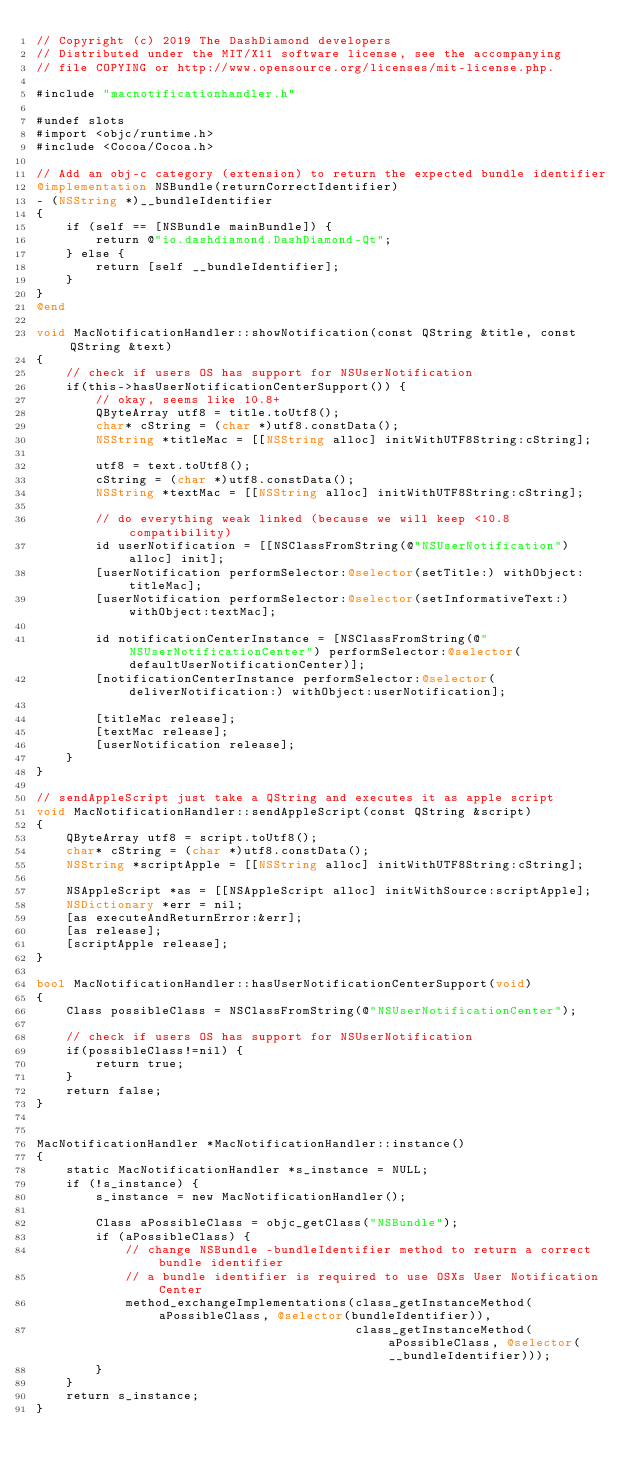Convert code to text. <code><loc_0><loc_0><loc_500><loc_500><_ObjectiveC_>// Copyright (c) 2019 The DashDiamond developers
// Distributed under the MIT/X11 software license, see the accompanying
// file COPYING or http://www.opensource.org/licenses/mit-license.php.

#include "macnotificationhandler.h"

#undef slots
#import <objc/runtime.h>
#include <Cocoa/Cocoa.h>

// Add an obj-c category (extension) to return the expected bundle identifier
@implementation NSBundle(returnCorrectIdentifier)
- (NSString *)__bundleIdentifier
{
    if (self == [NSBundle mainBundle]) {
        return @"io.dashdiamond.DashDiamond-Qt";
    } else {
        return [self __bundleIdentifier];
    }
}
@end

void MacNotificationHandler::showNotification(const QString &title, const QString &text)
{
    // check if users OS has support for NSUserNotification
    if(this->hasUserNotificationCenterSupport()) {
        // okay, seems like 10.8+
        QByteArray utf8 = title.toUtf8();
        char* cString = (char *)utf8.constData();
        NSString *titleMac = [[NSString alloc] initWithUTF8String:cString];

        utf8 = text.toUtf8();
        cString = (char *)utf8.constData();
        NSString *textMac = [[NSString alloc] initWithUTF8String:cString];

        // do everything weak linked (because we will keep <10.8 compatibility)
        id userNotification = [[NSClassFromString(@"NSUserNotification") alloc] init];
        [userNotification performSelector:@selector(setTitle:) withObject:titleMac];
        [userNotification performSelector:@selector(setInformativeText:) withObject:textMac];

        id notificationCenterInstance = [NSClassFromString(@"NSUserNotificationCenter") performSelector:@selector(defaultUserNotificationCenter)];
        [notificationCenterInstance performSelector:@selector(deliverNotification:) withObject:userNotification];

        [titleMac release];
        [textMac release];
        [userNotification release];
    }
}

// sendAppleScript just take a QString and executes it as apple script
void MacNotificationHandler::sendAppleScript(const QString &script)
{
    QByteArray utf8 = script.toUtf8();
    char* cString = (char *)utf8.constData();
    NSString *scriptApple = [[NSString alloc] initWithUTF8String:cString];

    NSAppleScript *as = [[NSAppleScript alloc] initWithSource:scriptApple];
    NSDictionary *err = nil;
    [as executeAndReturnError:&err];
    [as release];
    [scriptApple release];
}

bool MacNotificationHandler::hasUserNotificationCenterSupport(void)
{
    Class possibleClass = NSClassFromString(@"NSUserNotificationCenter");

    // check if users OS has support for NSUserNotification
    if(possibleClass!=nil) {
        return true;
    }
    return false;
}


MacNotificationHandler *MacNotificationHandler::instance()
{
    static MacNotificationHandler *s_instance = NULL;
    if (!s_instance) {
        s_instance = new MacNotificationHandler();
        
        Class aPossibleClass = objc_getClass("NSBundle");
        if (aPossibleClass) {
            // change NSBundle -bundleIdentifier method to return a correct bundle identifier
            // a bundle identifier is required to use OSXs User Notification Center
            method_exchangeImplementations(class_getInstanceMethod(aPossibleClass, @selector(bundleIdentifier)),
                                           class_getInstanceMethod(aPossibleClass, @selector(__bundleIdentifier)));
        }
    }
    return s_instance;
}
</code> 